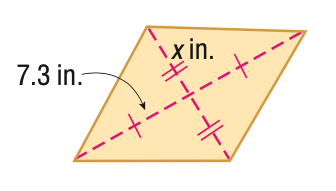Answer the mathemtical geometry problem and directly provide the correct option letter.
Question: Find x. A = 96 in^2.
Choices: A: 6.6 B: 6.9 C: 13.2 D: 13.7 A 